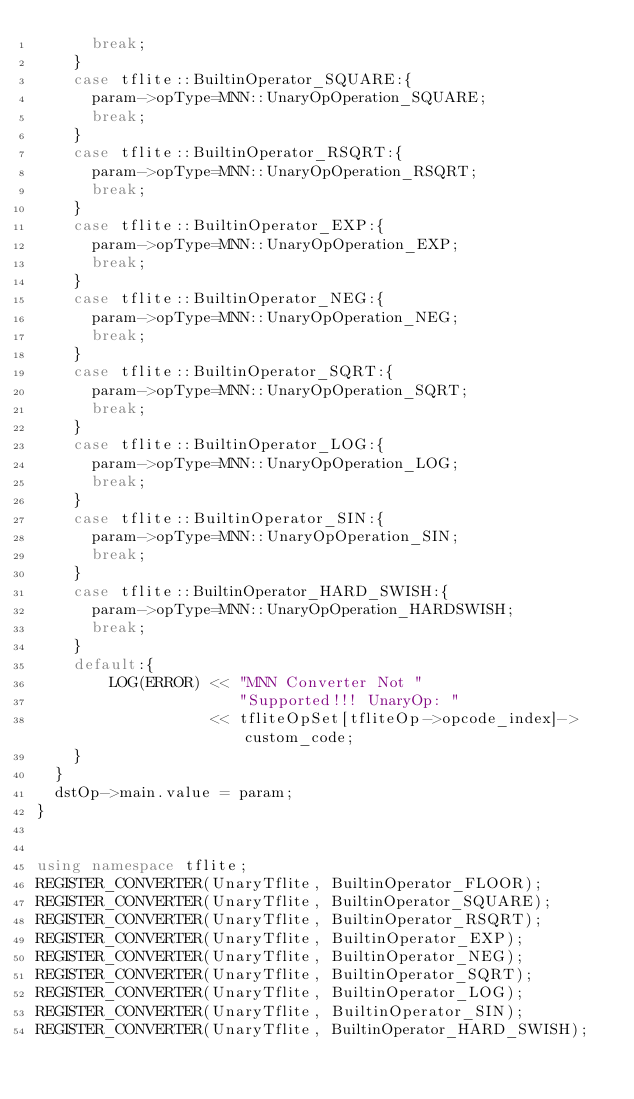Convert code to text. <code><loc_0><loc_0><loc_500><loc_500><_C++_>      break;
    }
    case tflite::BuiltinOperator_SQUARE:{
      param->opType=MNN::UnaryOpOperation_SQUARE;
      break;
    }
    case tflite::BuiltinOperator_RSQRT:{
      param->opType=MNN::UnaryOpOperation_RSQRT;
      break;
    }
    case tflite::BuiltinOperator_EXP:{
      param->opType=MNN::UnaryOpOperation_EXP;
      break;
    }
    case tflite::BuiltinOperator_NEG:{
      param->opType=MNN::UnaryOpOperation_NEG;
      break;
    }
    case tflite::BuiltinOperator_SQRT:{
      param->opType=MNN::UnaryOpOperation_SQRT;
      break;
    }
    case tflite::BuiltinOperator_LOG:{
      param->opType=MNN::UnaryOpOperation_LOG;
      break;
    }
    case tflite::BuiltinOperator_SIN:{
      param->opType=MNN::UnaryOpOperation_SIN;
      break;
    }
    case tflite::BuiltinOperator_HARD_SWISH:{
      param->opType=MNN::UnaryOpOperation_HARDSWISH;
      break;
    }
    default:{
        LOG(ERROR) << "MNN Converter Not "
                      "Supported!!! UnaryOp: "
                   << tfliteOpSet[tfliteOp->opcode_index]->custom_code;
    }
  }
  dstOp->main.value = param;
}


using namespace tflite;
REGISTER_CONVERTER(UnaryTflite, BuiltinOperator_FLOOR);
REGISTER_CONVERTER(UnaryTflite, BuiltinOperator_SQUARE);
REGISTER_CONVERTER(UnaryTflite, BuiltinOperator_RSQRT);
REGISTER_CONVERTER(UnaryTflite, BuiltinOperator_EXP);
REGISTER_CONVERTER(UnaryTflite, BuiltinOperator_NEG);
REGISTER_CONVERTER(UnaryTflite, BuiltinOperator_SQRT);
REGISTER_CONVERTER(UnaryTflite, BuiltinOperator_LOG);
REGISTER_CONVERTER(UnaryTflite, BuiltinOperator_SIN);
REGISTER_CONVERTER(UnaryTflite, BuiltinOperator_HARD_SWISH);
</code> 